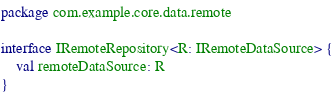Convert code to text. <code><loc_0><loc_0><loc_500><loc_500><_Kotlin_>package com.example.core.data.remote

interface IRemoteRepository<R: IRemoteDataSource> {
    val remoteDataSource: R
}
</code> 